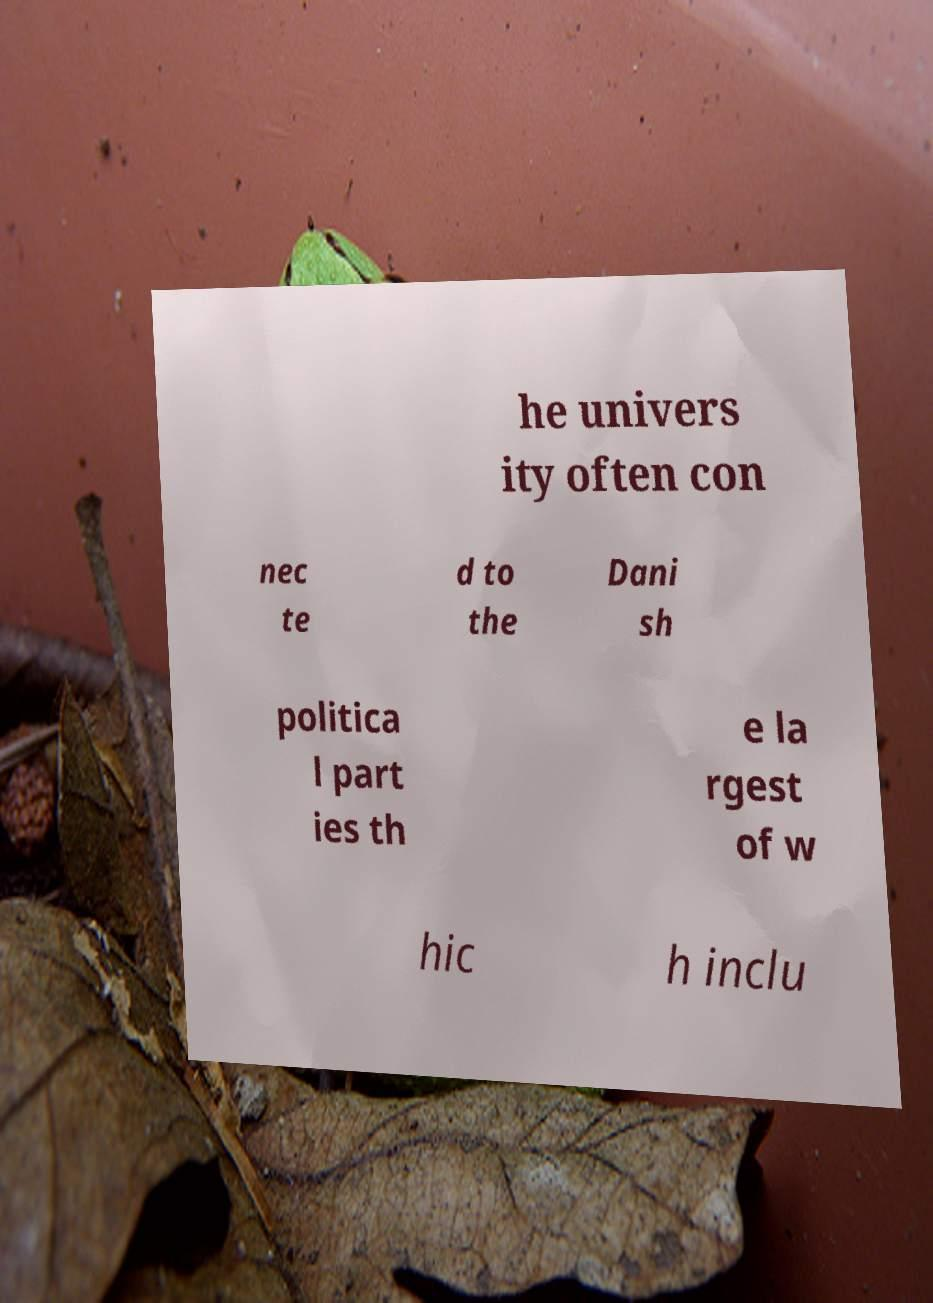There's text embedded in this image that I need extracted. Can you transcribe it verbatim? he univers ity often con nec te d to the Dani sh politica l part ies th e la rgest of w hic h inclu 